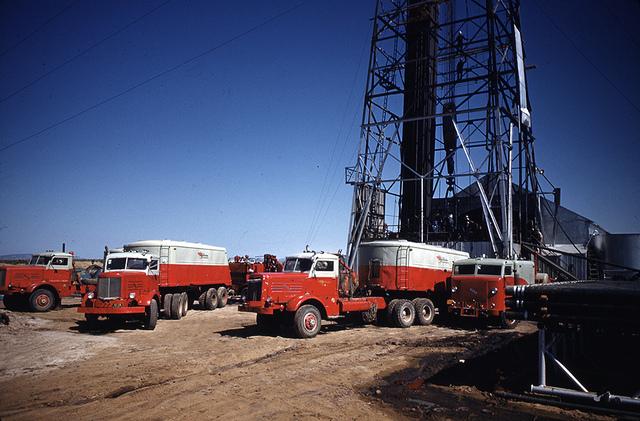What color is the dirt?
Quick response, please. Brown. How many red and white trucks are there?
Keep it brief. 4. What kind of tower is this?
Quick response, please. Cell. 